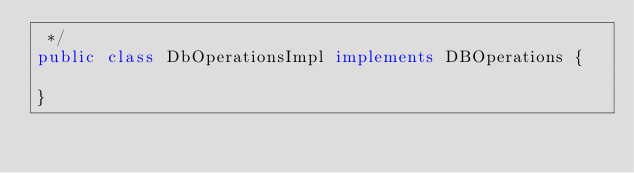<code> <loc_0><loc_0><loc_500><loc_500><_Java_> */
public class DbOperationsImpl implements DBOperations {

}
</code> 